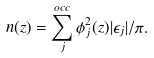<formula> <loc_0><loc_0><loc_500><loc_500>n ( z ) = \sum _ { j } ^ { o c c } \phi _ { j } ^ { 2 } ( z ) | \epsilon _ { j } | / \pi .</formula> 